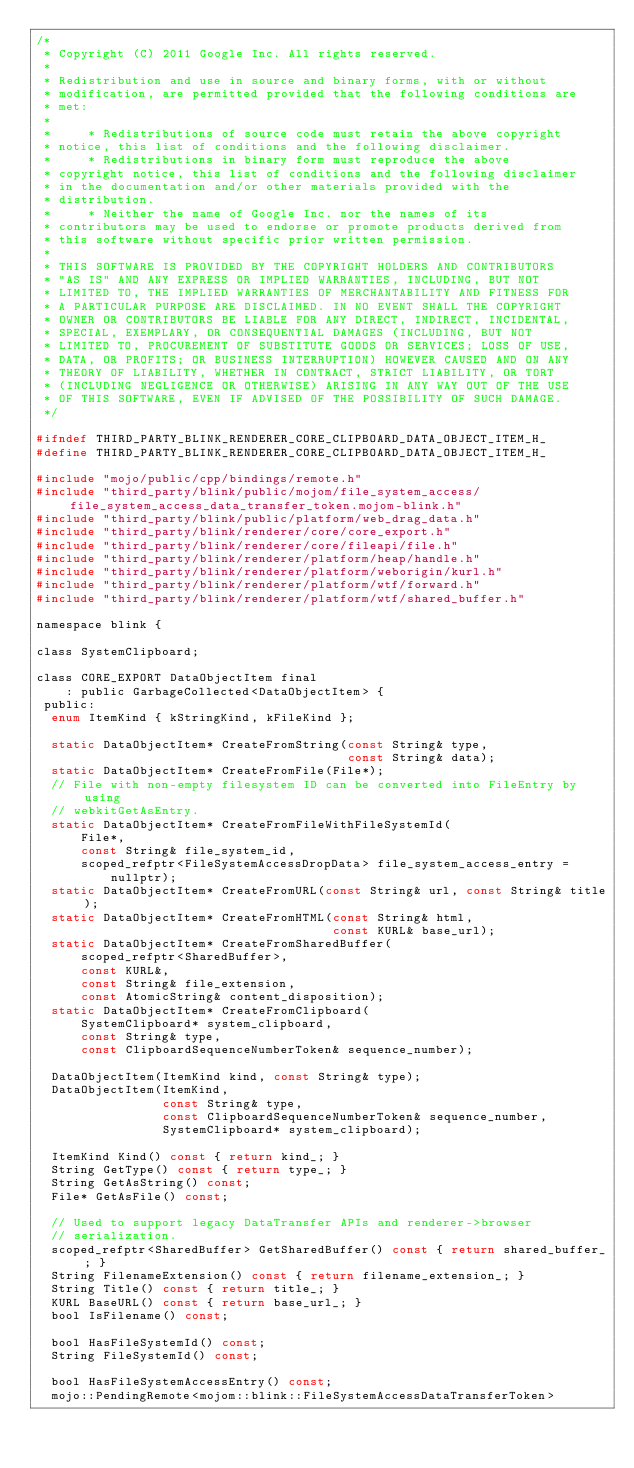Convert code to text. <code><loc_0><loc_0><loc_500><loc_500><_C_>/*
 * Copyright (C) 2011 Google Inc. All rights reserved.
 *
 * Redistribution and use in source and binary forms, with or without
 * modification, are permitted provided that the following conditions are
 * met:
 *
 *     * Redistributions of source code must retain the above copyright
 * notice, this list of conditions and the following disclaimer.
 *     * Redistributions in binary form must reproduce the above
 * copyright notice, this list of conditions and the following disclaimer
 * in the documentation and/or other materials provided with the
 * distribution.
 *     * Neither the name of Google Inc. nor the names of its
 * contributors may be used to endorse or promote products derived from
 * this software without specific prior written permission.
 *
 * THIS SOFTWARE IS PROVIDED BY THE COPYRIGHT HOLDERS AND CONTRIBUTORS
 * "AS IS" AND ANY EXPRESS OR IMPLIED WARRANTIES, INCLUDING, BUT NOT
 * LIMITED TO, THE IMPLIED WARRANTIES OF MERCHANTABILITY AND FITNESS FOR
 * A PARTICULAR PURPOSE ARE DISCLAIMED. IN NO EVENT SHALL THE COPYRIGHT
 * OWNER OR CONTRIBUTORS BE LIABLE FOR ANY DIRECT, INDIRECT, INCIDENTAL,
 * SPECIAL, EXEMPLARY, OR CONSEQUENTIAL DAMAGES (INCLUDING, BUT NOT
 * LIMITED TO, PROCUREMENT OF SUBSTITUTE GOODS OR SERVICES; LOSS OF USE,
 * DATA, OR PROFITS; OR BUSINESS INTERRUPTION) HOWEVER CAUSED AND ON ANY
 * THEORY OF LIABILITY, WHETHER IN CONTRACT, STRICT LIABILITY, OR TORT
 * (INCLUDING NEGLIGENCE OR OTHERWISE) ARISING IN ANY WAY OUT OF THE USE
 * OF THIS SOFTWARE, EVEN IF ADVISED OF THE POSSIBILITY OF SUCH DAMAGE.
 */

#ifndef THIRD_PARTY_BLINK_RENDERER_CORE_CLIPBOARD_DATA_OBJECT_ITEM_H_
#define THIRD_PARTY_BLINK_RENDERER_CORE_CLIPBOARD_DATA_OBJECT_ITEM_H_

#include "mojo/public/cpp/bindings/remote.h"
#include "third_party/blink/public/mojom/file_system_access/file_system_access_data_transfer_token.mojom-blink.h"
#include "third_party/blink/public/platform/web_drag_data.h"
#include "third_party/blink/renderer/core/core_export.h"
#include "third_party/blink/renderer/core/fileapi/file.h"
#include "third_party/blink/renderer/platform/heap/handle.h"
#include "third_party/blink/renderer/platform/weborigin/kurl.h"
#include "third_party/blink/renderer/platform/wtf/forward.h"
#include "third_party/blink/renderer/platform/wtf/shared_buffer.h"

namespace blink {

class SystemClipboard;

class CORE_EXPORT DataObjectItem final
    : public GarbageCollected<DataObjectItem> {
 public:
  enum ItemKind { kStringKind, kFileKind };

  static DataObjectItem* CreateFromString(const String& type,
                                          const String& data);
  static DataObjectItem* CreateFromFile(File*);
  // File with non-empty filesystem ID can be converted into FileEntry by using
  // webkitGetAsEntry.
  static DataObjectItem* CreateFromFileWithFileSystemId(
      File*,
      const String& file_system_id,
      scoped_refptr<FileSystemAccessDropData> file_system_access_entry =
          nullptr);
  static DataObjectItem* CreateFromURL(const String& url, const String& title);
  static DataObjectItem* CreateFromHTML(const String& html,
                                        const KURL& base_url);
  static DataObjectItem* CreateFromSharedBuffer(
      scoped_refptr<SharedBuffer>,
      const KURL&,
      const String& file_extension,
      const AtomicString& content_disposition);
  static DataObjectItem* CreateFromClipboard(
      SystemClipboard* system_clipboard,
      const String& type,
      const ClipboardSequenceNumberToken& sequence_number);

  DataObjectItem(ItemKind kind, const String& type);
  DataObjectItem(ItemKind,
                 const String& type,
                 const ClipboardSequenceNumberToken& sequence_number,
                 SystemClipboard* system_clipboard);

  ItemKind Kind() const { return kind_; }
  String GetType() const { return type_; }
  String GetAsString() const;
  File* GetAsFile() const;

  // Used to support legacy DataTransfer APIs and renderer->browser
  // serialization.
  scoped_refptr<SharedBuffer> GetSharedBuffer() const { return shared_buffer_; }
  String FilenameExtension() const { return filename_extension_; }
  String Title() const { return title_; }
  KURL BaseURL() const { return base_url_; }
  bool IsFilename() const;

  bool HasFileSystemId() const;
  String FileSystemId() const;

  bool HasFileSystemAccessEntry() const;
  mojo::PendingRemote<mojom::blink::FileSystemAccessDataTransferToken></code> 